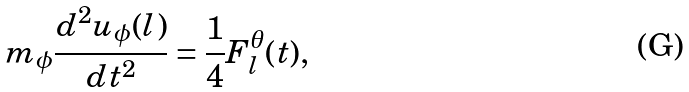Convert formula to latex. <formula><loc_0><loc_0><loc_500><loc_500>m _ { \phi } \frac { d ^ { 2 } u _ { \phi } ( l ) } { d t ^ { 2 } } = \frac { 1 } { 4 } F ^ { \theta } _ { l } ( t ) ,</formula> 